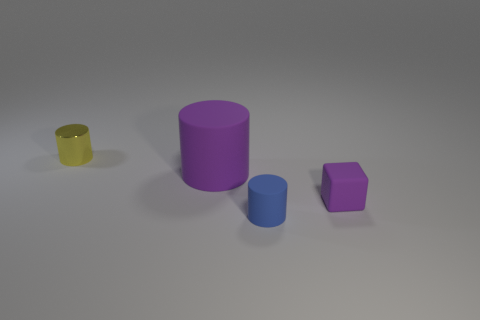There is a blue cylinder that is made of the same material as the large purple cylinder; what is its size?
Give a very brief answer. Small. Is there a tiny rubber cylinder that has the same color as the tiny cube?
Provide a succinct answer. No. There is a purple rubber cube; does it have the same size as the matte cylinder that is behind the blue matte thing?
Your answer should be very brief. No. How many small purple cubes are on the right side of the small yellow thing behind the small cylinder that is in front of the large object?
Offer a terse response. 1. What size is the rubber cylinder that is the same color as the small cube?
Keep it short and to the point. Large. There is a blue matte object; are there any purple rubber blocks in front of it?
Offer a terse response. No. What shape is the small purple thing?
Offer a very short reply. Cube. The thing that is behind the purple thing that is to the left of the small cylinder in front of the tiny shiny object is what shape?
Give a very brief answer. Cylinder. How many other objects are there of the same shape as the large matte object?
Your answer should be very brief. 2. What material is the small object that is left of the matte object that is to the left of the tiny blue rubber object?
Make the answer very short. Metal. 